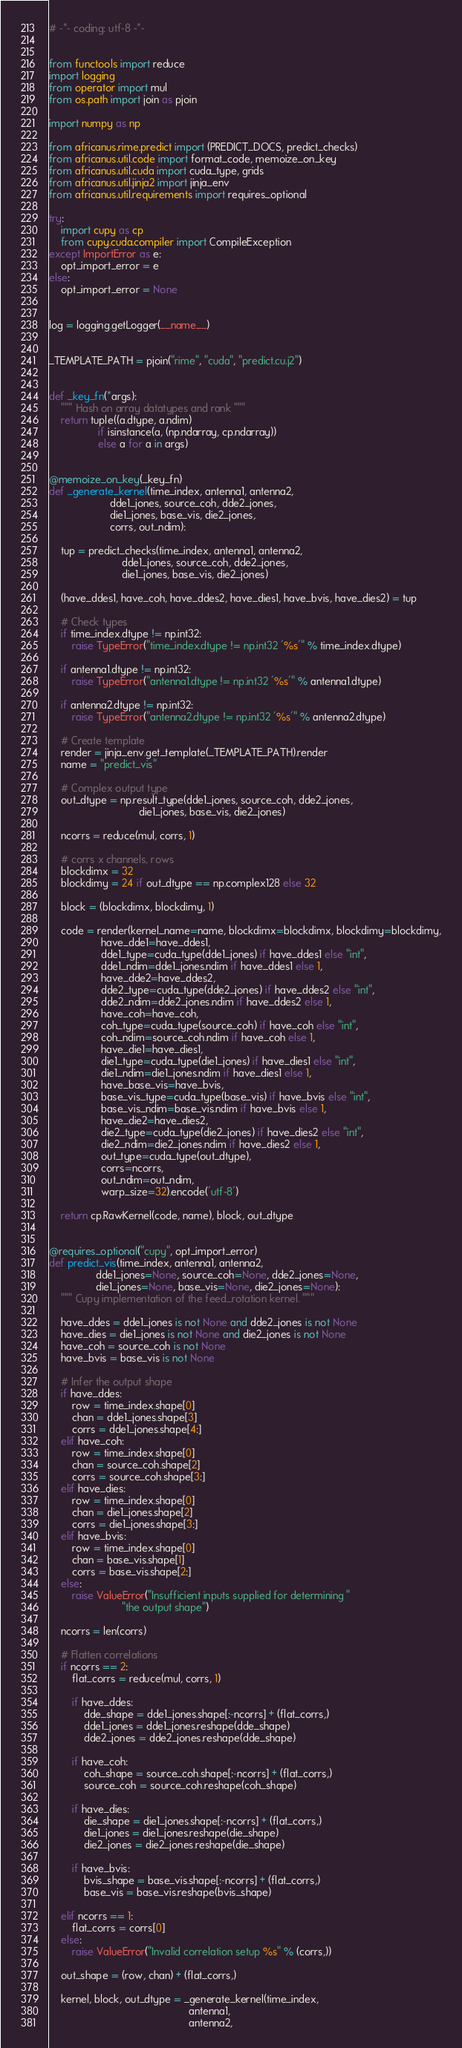<code> <loc_0><loc_0><loc_500><loc_500><_Python_># -*- coding: utf-8 -*-


from functools import reduce
import logging
from operator import mul
from os.path import join as pjoin

import numpy as np

from africanus.rime.predict import (PREDICT_DOCS, predict_checks)
from africanus.util.code import format_code, memoize_on_key
from africanus.util.cuda import cuda_type, grids
from africanus.util.jinja2 import jinja_env
from africanus.util.requirements import requires_optional

try:
    import cupy as cp
    from cupy.cuda.compiler import CompileException
except ImportError as e:
    opt_import_error = e
else:
    opt_import_error = None


log = logging.getLogger(__name__)


_TEMPLATE_PATH = pjoin("rime", "cuda", "predict.cu.j2")


def _key_fn(*args):
    """ Hash on array datatypes and rank """
    return tuple((a.dtype, a.ndim)
                 if isinstance(a, (np.ndarray, cp.ndarray))
                 else a for a in args)


@memoize_on_key(_key_fn)
def _generate_kernel(time_index, antenna1, antenna2,
                     dde1_jones, source_coh, dde2_jones,
                     die1_jones, base_vis, die2_jones,
                     corrs, out_ndim):

    tup = predict_checks(time_index, antenna1, antenna2,
                         dde1_jones, source_coh, dde2_jones,
                         die1_jones, base_vis, die2_jones)

    (have_ddes1, have_coh, have_ddes2, have_dies1, have_bvis, have_dies2) = tup

    # Check types
    if time_index.dtype != np.int32:
        raise TypeError("time_index.dtype != np.int32 '%s'" % time_index.dtype)

    if antenna1.dtype != np.int32:
        raise TypeError("antenna1.dtype != np.int32 '%s'" % antenna1.dtype)

    if antenna2.dtype != np.int32:
        raise TypeError("antenna2.dtype != np.int32 '%s'" % antenna2.dtype)

    # Create template
    render = jinja_env.get_template(_TEMPLATE_PATH).render
    name = "predict_vis"

    # Complex output type
    out_dtype = np.result_type(dde1_jones, source_coh, dde2_jones,
                               die1_jones, base_vis, die2_jones)

    ncorrs = reduce(mul, corrs, 1)

    # corrs x channels, rows
    blockdimx = 32
    blockdimy = 24 if out_dtype == np.complex128 else 32

    block = (blockdimx, blockdimy, 1)

    code = render(kernel_name=name, blockdimx=blockdimx, blockdimy=blockdimy,
                  have_dde1=have_ddes1,
                  dde1_type=cuda_type(dde1_jones) if have_ddes1 else "int",
                  dde1_ndim=dde1_jones.ndim if have_ddes1 else 1,
                  have_dde2=have_ddes2,
                  dde2_type=cuda_type(dde2_jones) if have_ddes2 else "int",
                  dde2_ndim=dde2_jones.ndim if have_ddes2 else 1,
                  have_coh=have_coh,
                  coh_type=cuda_type(source_coh) if have_coh else "int",
                  coh_ndim=source_coh.ndim if have_coh else 1,
                  have_die1=have_dies1,
                  die1_type=cuda_type(die1_jones) if have_dies1 else "int",
                  die1_ndim=die1_jones.ndim if have_dies1 else 1,
                  have_base_vis=have_bvis,
                  base_vis_type=cuda_type(base_vis) if have_bvis else "int",
                  base_vis_ndim=base_vis.ndim if have_bvis else 1,
                  have_die2=have_dies2,
                  die2_type=cuda_type(die2_jones) if have_dies2 else "int",
                  die2_ndim=die2_jones.ndim if have_dies2 else 1,
                  out_type=cuda_type(out_dtype),
                  corrs=ncorrs,
                  out_ndim=out_ndim,
                  warp_size=32).encode('utf-8')

    return cp.RawKernel(code, name), block, out_dtype


@requires_optional("cupy", opt_import_error)
def predict_vis(time_index, antenna1, antenna2,
                dde1_jones=None, source_coh=None, dde2_jones=None,
                die1_jones=None, base_vis=None, die2_jones=None):
    """ Cupy implementation of the feed_rotation kernel. """

    have_ddes = dde1_jones is not None and dde2_jones is not None
    have_dies = die1_jones is not None and die2_jones is not None
    have_coh = source_coh is not None
    have_bvis = base_vis is not None

    # Infer the output shape
    if have_ddes:
        row = time_index.shape[0]
        chan = dde1_jones.shape[3]
        corrs = dde1_jones.shape[4:]
    elif have_coh:
        row = time_index.shape[0]
        chan = source_coh.shape[2]
        corrs = source_coh.shape[3:]
    elif have_dies:
        row = time_index.shape[0]
        chan = die1_jones.shape[2]
        corrs = die1_jones.shape[3:]
    elif have_bvis:
        row = time_index.shape[0]
        chan = base_vis.shape[1]
        corrs = base_vis.shape[2:]
    else:
        raise ValueError("Insufficient inputs supplied for determining "
                         "the output shape")

    ncorrs = len(corrs)

    # Flatten correlations
    if ncorrs == 2:
        flat_corrs = reduce(mul, corrs, 1)

        if have_ddes:
            dde_shape = dde1_jones.shape[:-ncorrs] + (flat_corrs,)
            dde1_jones = dde1_jones.reshape(dde_shape)
            dde2_jones = dde2_jones.reshape(dde_shape)

        if have_coh:
            coh_shape = source_coh.shape[:-ncorrs] + (flat_corrs,)
            source_coh = source_coh.reshape(coh_shape)

        if have_dies:
            die_shape = die1_jones.shape[:-ncorrs] + (flat_corrs,)
            die1_jones = die1_jones.reshape(die_shape)
            die2_jones = die2_jones.reshape(die_shape)

        if have_bvis:
            bvis_shape = base_vis.shape[:-ncorrs] + (flat_corrs,)
            base_vis = base_vis.reshape(bvis_shape)

    elif ncorrs == 1:
        flat_corrs = corrs[0]
    else:
        raise ValueError("Invalid correlation setup %s" % (corrs,))

    out_shape = (row, chan) + (flat_corrs,)

    kernel, block, out_dtype = _generate_kernel(time_index,
                                                antenna1,
                                                antenna2,</code> 